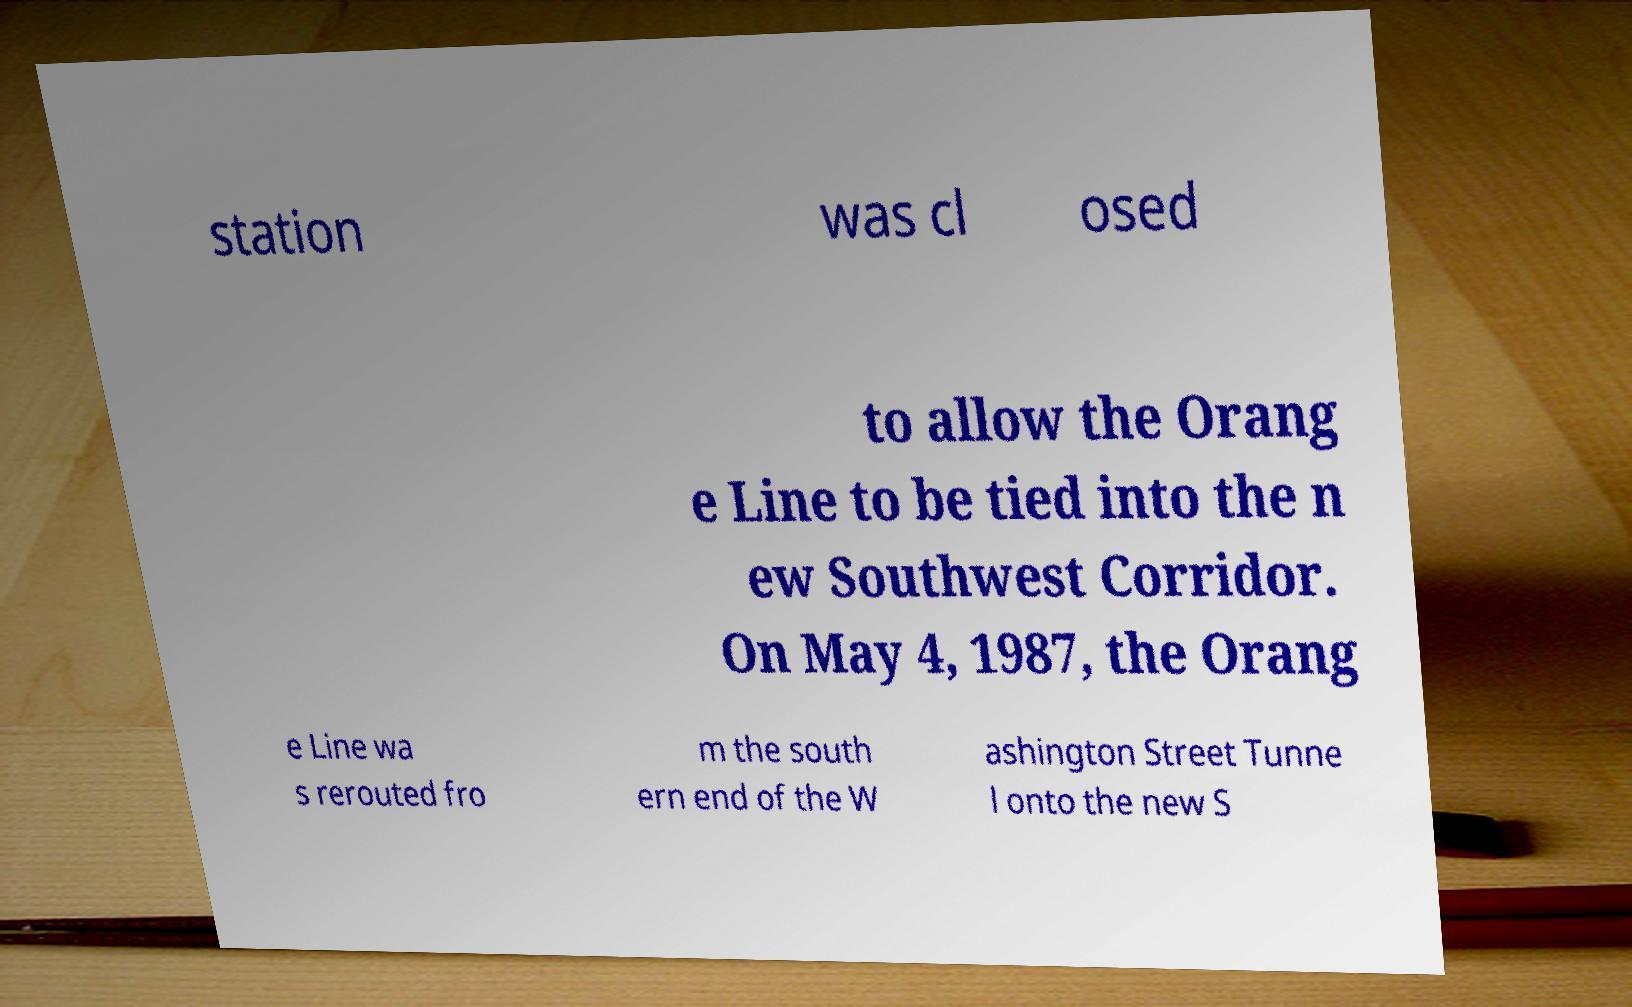Could you assist in decoding the text presented in this image and type it out clearly? station was cl osed to allow the Orang e Line to be tied into the n ew Southwest Corridor. On May 4, 1987, the Orang e Line wa s rerouted fro m the south ern end of the W ashington Street Tunne l onto the new S 